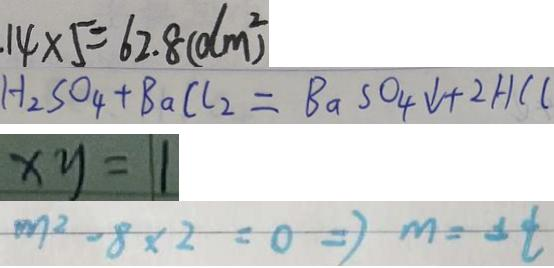Convert formula to latex. <formula><loc_0><loc_0><loc_500><loc_500>1 4 \times 5 = 6 2 . 8 ( d m ^ { 2 } ) 
 H _ { 2 } S O _ { 4 } + B a C l _ { 2 } = B a S O _ { 4 } \downarrow + 2 H C C 
 x y = 1 
 m ^ { 2 } - 8 \times 2 = 0 \Rightarrow m = \pm t</formula> 